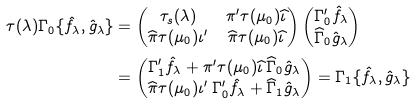<formula> <loc_0><loc_0><loc_500><loc_500>\tau ( \lambda ) \Gamma _ { 0 } \{ \hat { f } _ { \lambda } , \hat { g } _ { \lambda } \} & = \begin{pmatrix} \tau _ { s } ( \lambda ) & \pi ^ { \prime } \tau ( \mu _ { 0 } ) \widehat { \iota } \\ \widehat { \pi } \tau ( \mu _ { 0 } ) \iota ^ { \prime } & \widehat { \pi } \tau ( \mu _ { 0 } ) \widehat { \iota } \end{pmatrix} \begin{pmatrix} \Gamma _ { 0 } ^ { \prime } \hat { f } _ { \lambda } \\ \widehat { \Gamma } _ { 0 } \hat { g } _ { \lambda } \end{pmatrix} \\ & = \begin{pmatrix} \Gamma _ { 1 } ^ { \prime } \hat { f } _ { \lambda } + \pi ^ { \prime } \tau ( \mu _ { 0 } ) \widehat { \iota } \, \widehat { \Gamma } _ { 0 } \hat { g } _ { \lambda } \\ \widehat { \pi } \tau ( \mu _ { 0 } ) \iota ^ { \prime } \, \Gamma _ { 0 } ^ { \prime } \hat { f } _ { \lambda } + \widehat { \Gamma } _ { 1 } \hat { g } _ { \lambda } \end{pmatrix} = \Gamma _ { 1 } \{ \hat { f } _ { \lambda } , \hat { g } _ { \lambda } \}</formula> 